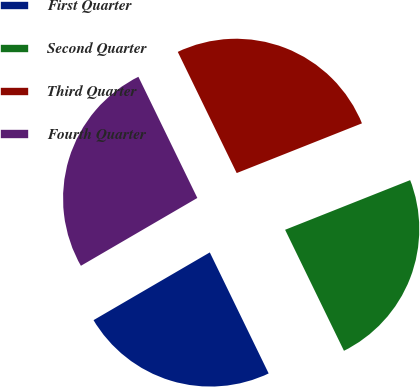Convert chart. <chart><loc_0><loc_0><loc_500><loc_500><pie_chart><fcel>First Quarter<fcel>Second Quarter<fcel>Third Quarter<fcel>Fourth Quarter<nl><fcel>23.81%<fcel>23.81%<fcel>26.19%<fcel>26.19%<nl></chart> 